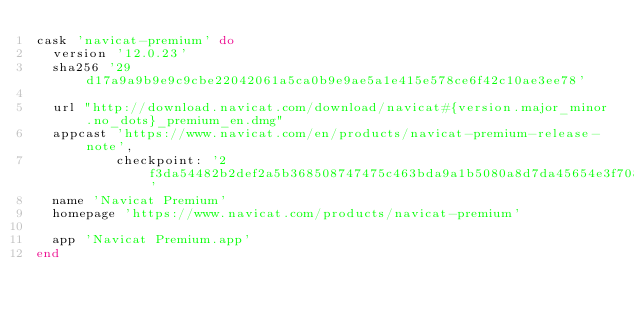Convert code to text. <code><loc_0><loc_0><loc_500><loc_500><_Ruby_>cask 'navicat-premium' do
  version '12.0.23'
  sha256 '29d17a9a9b9e9c9cbe22042061a5ca0b9e9ae5a1e415e578ce6f42c10ae3ee78'

  url "http://download.navicat.com/download/navicat#{version.major_minor.no_dots}_premium_en.dmg"
  appcast 'https://www.navicat.com/en/products/navicat-premium-release-note',
          checkpoint: '2f3da54482b2def2a5b368508747475c463bda9a1b5080a8d7da45654e3f7087'
  name 'Navicat Premium'
  homepage 'https://www.navicat.com/products/navicat-premium'

  app 'Navicat Premium.app'
end
</code> 